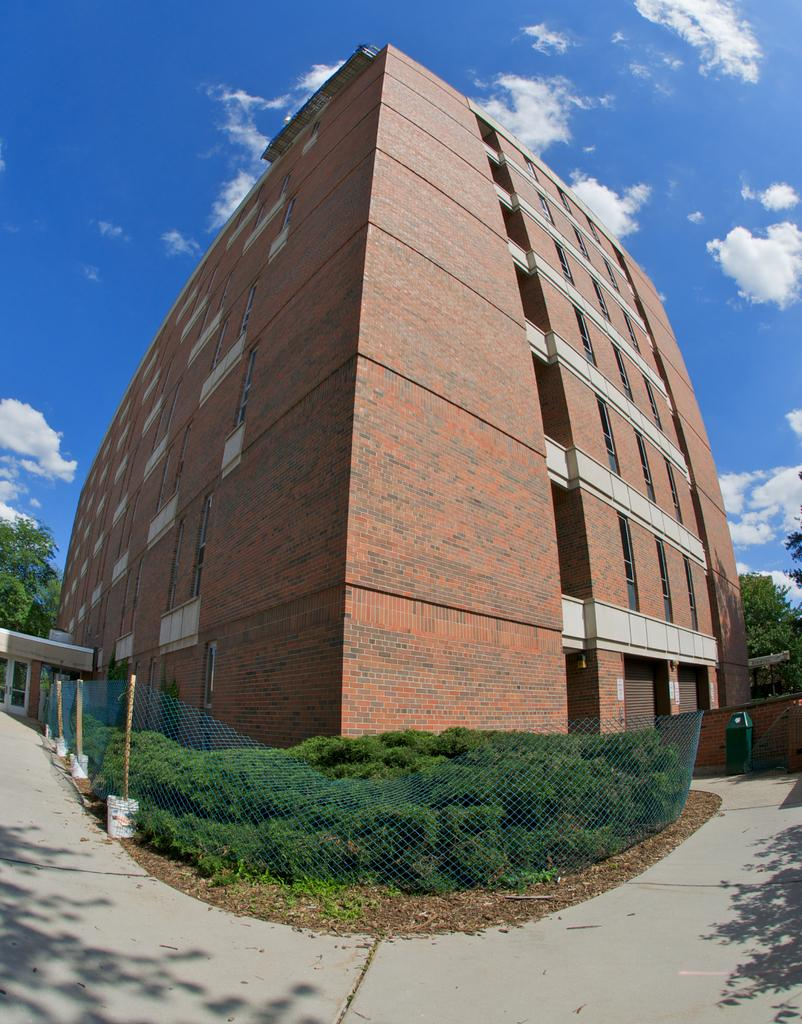What type of structure is present in the image? There is a building in the image. What other natural elements can be seen in the image? There are trees in the image. What can be seen in the distance in the image? The sky is visible in the background of the image. What type of toy is being burned in the image? There is no toy or any indication of fire or burning in the image. 